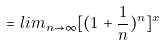Convert formula to latex. <formula><loc_0><loc_0><loc_500><loc_500>= l i m _ { n \rightarrow \infty } [ ( 1 + \frac { 1 } { n } ) ^ { n } ] ^ { x }</formula> 